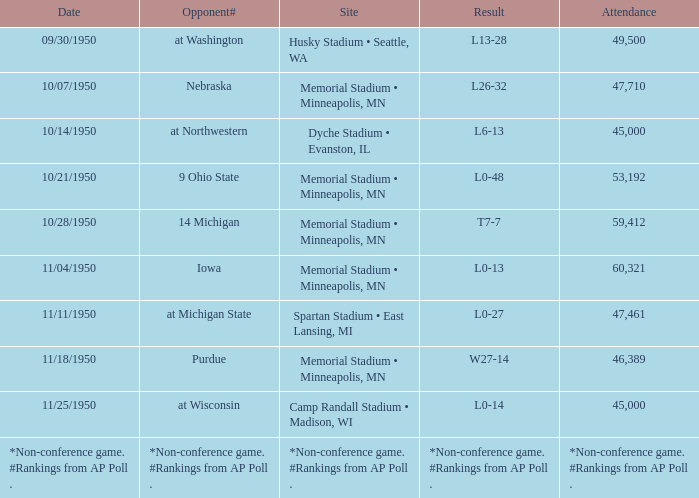What is the date when the opponent# is iowa? 11/04/1950. 